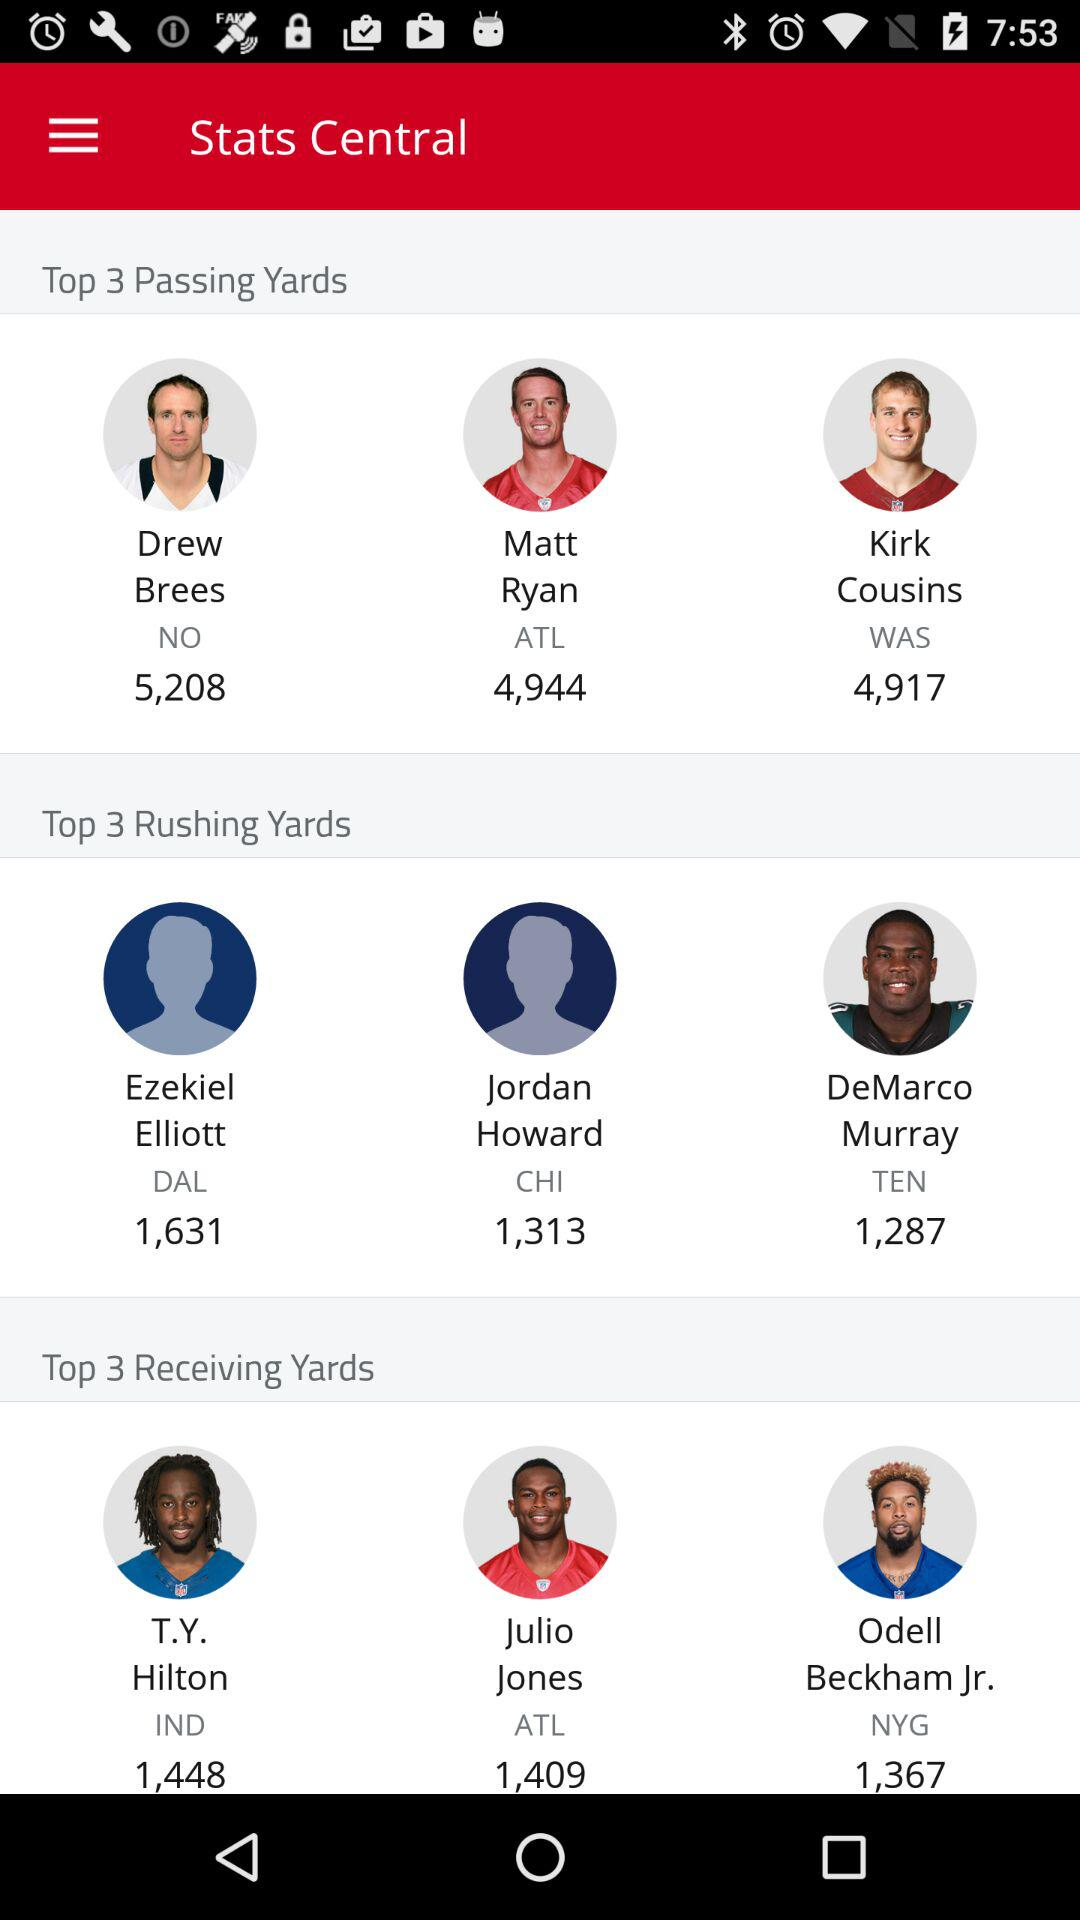Who are the top 3 passing yards? The top 3 passing yards are Drew Brees, Matt Ryan and Kirk Cousins. 